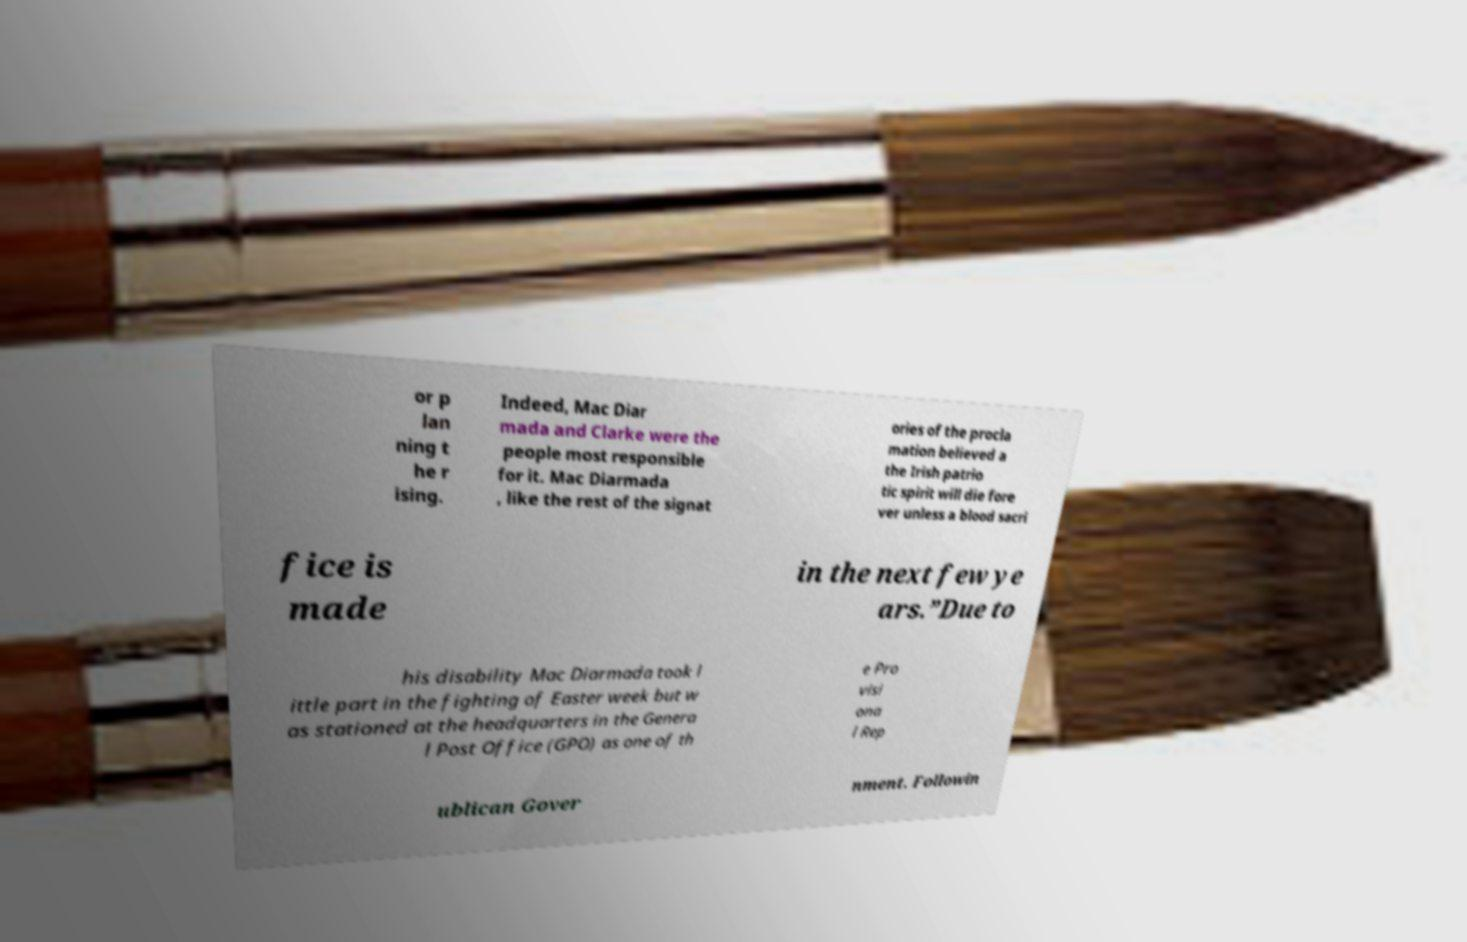Can you read and provide the text displayed in the image?This photo seems to have some interesting text. Can you extract and type it out for me? or p lan ning t he r ising. Indeed, Mac Diar mada and Clarke were the people most responsible for it. Mac Diarmada , like the rest of the signat ories of the procla mation believed a the Irish patrio tic spirit will die fore ver unless a blood sacri fice is made in the next few ye ars.”Due to his disability Mac Diarmada took l ittle part in the fighting of Easter week but w as stationed at the headquarters in the Genera l Post Office (GPO) as one of th e Pro visi ona l Rep ublican Gover nment. Followin 